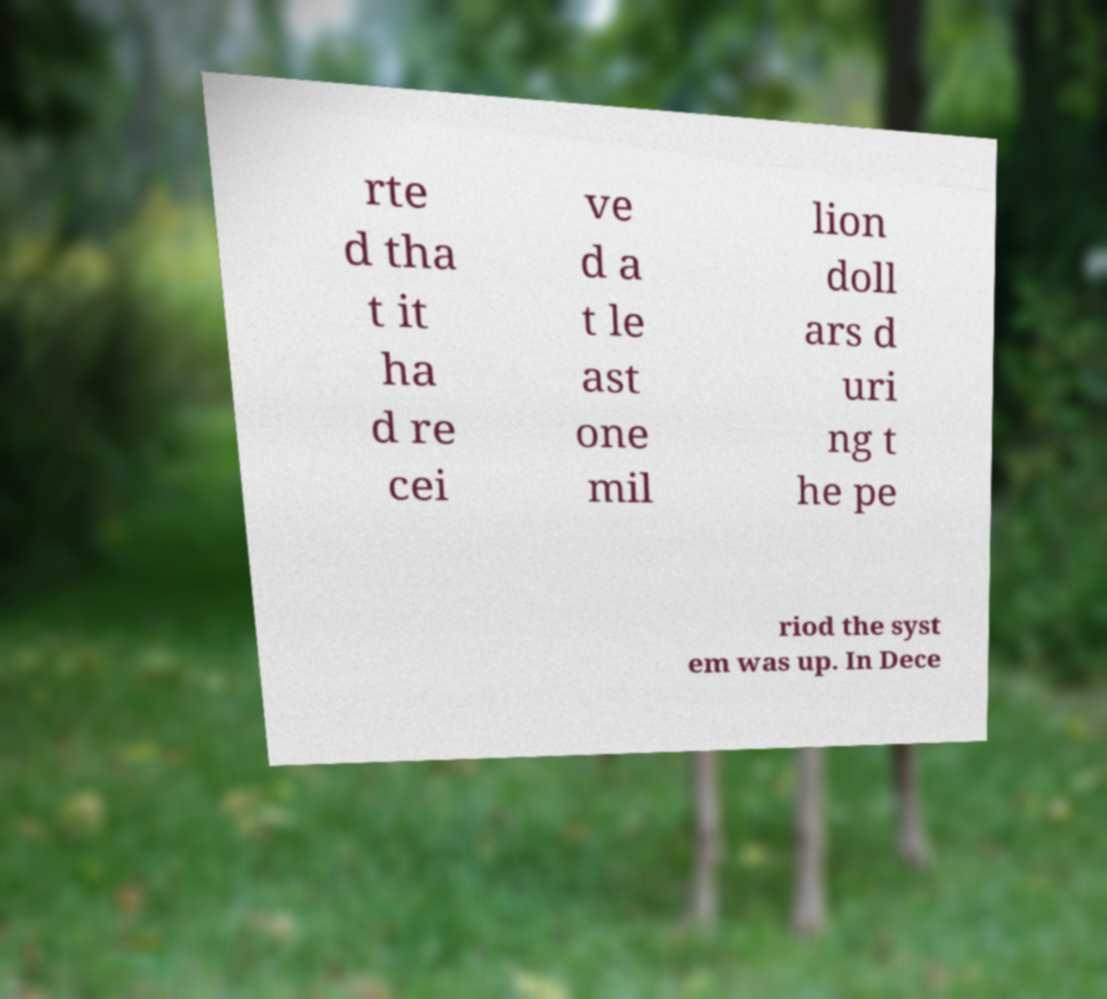Can you read and provide the text displayed in the image?This photo seems to have some interesting text. Can you extract and type it out for me? rte d tha t it ha d re cei ve d a t le ast one mil lion doll ars d uri ng t he pe riod the syst em was up. In Dece 